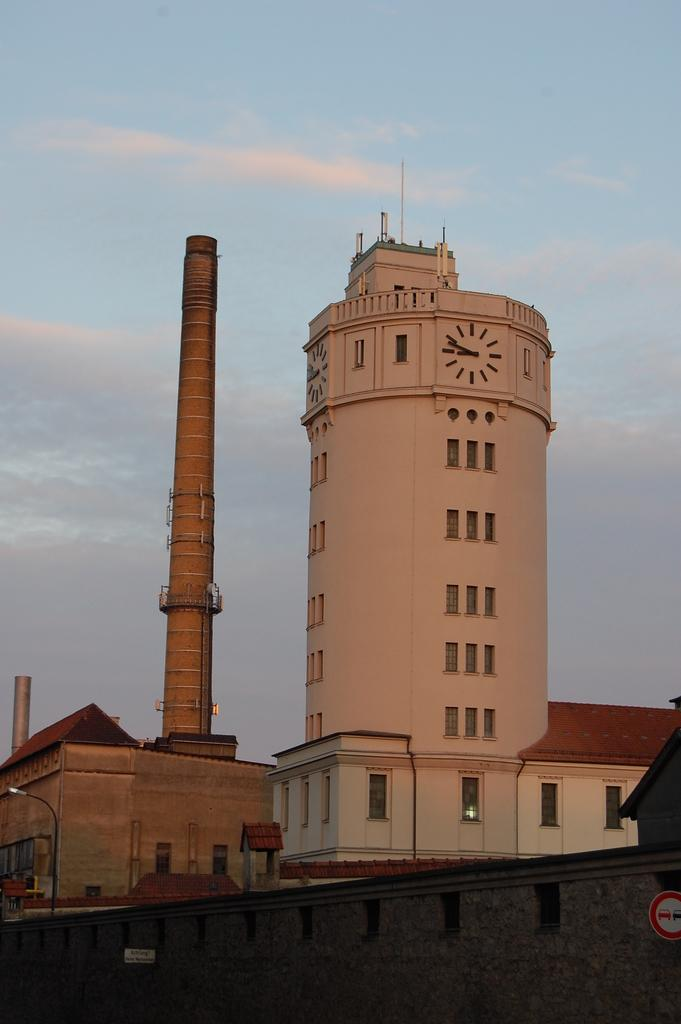What type of structures can be seen in the image? There are buildings in the image. What type of lighting is present in the image? There are lamp posts in the image. What type of information might be conveyed by the sign board in the image? The sign board on a wall in the image might convey information such as directions, advertisements, or warnings. Can you tell me how many deer are grazing near the buildings in the image? There are no deer present in the image; it features buildings, lamp posts, and a sign board. What type of argument is taking place between the lamp posts in the image? There is no argument taking place between the lamp posts in the image; they are inanimate objects and do not engage in arguments. 